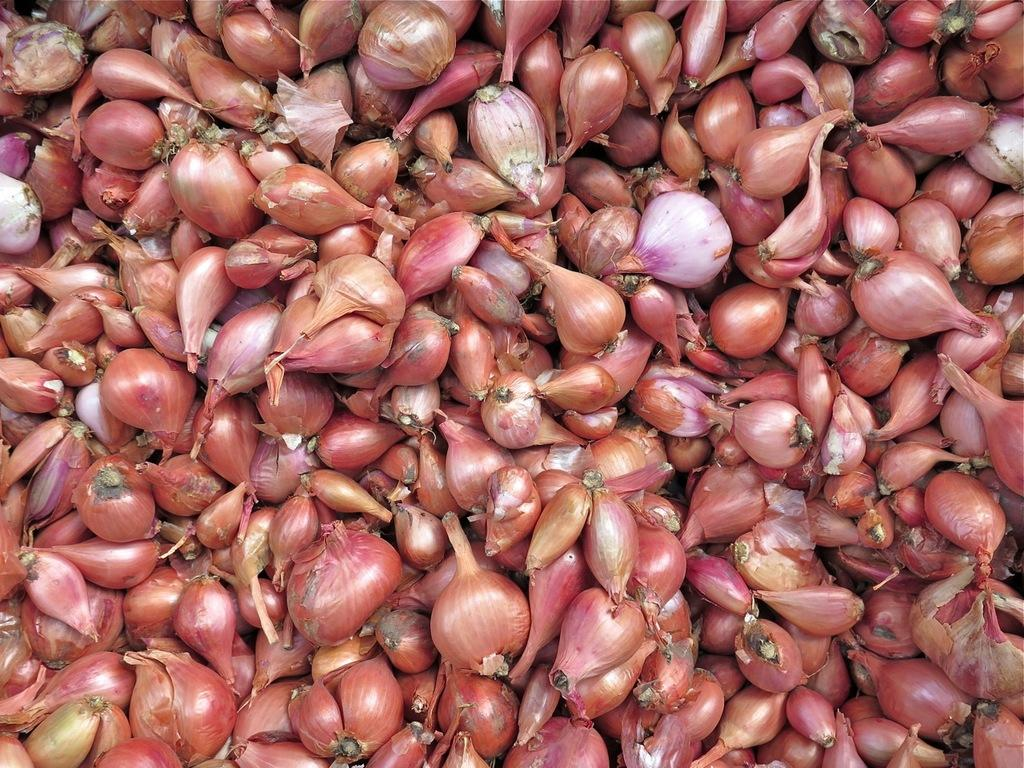What type of vegetable is present in the image? There are onions in the image. How do the onions care for the giant's lip in the image? There are no giants or lips present in the image, and therefore no such interaction can be observed. 